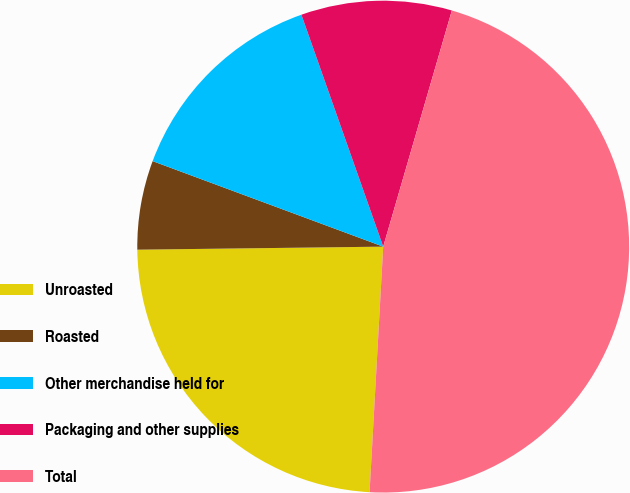Convert chart. <chart><loc_0><loc_0><loc_500><loc_500><pie_chart><fcel>Unroasted<fcel>Roasted<fcel>Other merchandise held for<fcel>Packaging and other supplies<fcel>Total<nl><fcel>23.92%<fcel>5.85%<fcel>13.95%<fcel>9.9%<fcel>46.38%<nl></chart> 